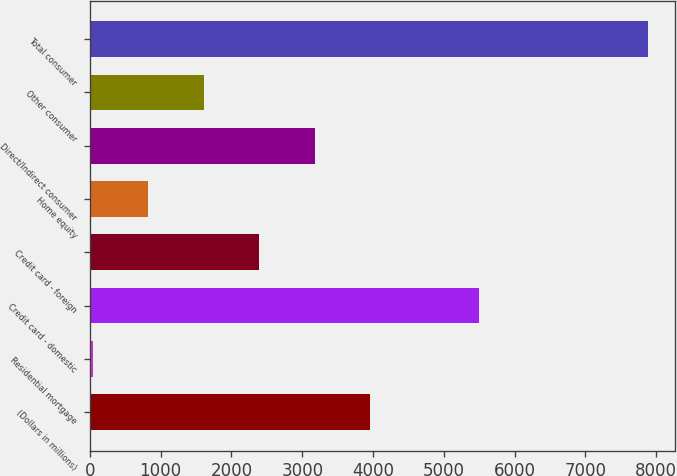Convert chart to OTSL. <chart><loc_0><loc_0><loc_500><loc_500><bar_chart><fcel>(Dollars in millions)<fcel>Residential mortgage<fcel>Credit card - domestic<fcel>Credit card - foreign<fcel>Home equity<fcel>Direct/Indirect consumer<fcel>Other consumer<fcel>Total consumer<nl><fcel>3958.5<fcel>39<fcel>5494<fcel>2390.7<fcel>822.9<fcel>3174.6<fcel>1606.8<fcel>7878<nl></chart> 